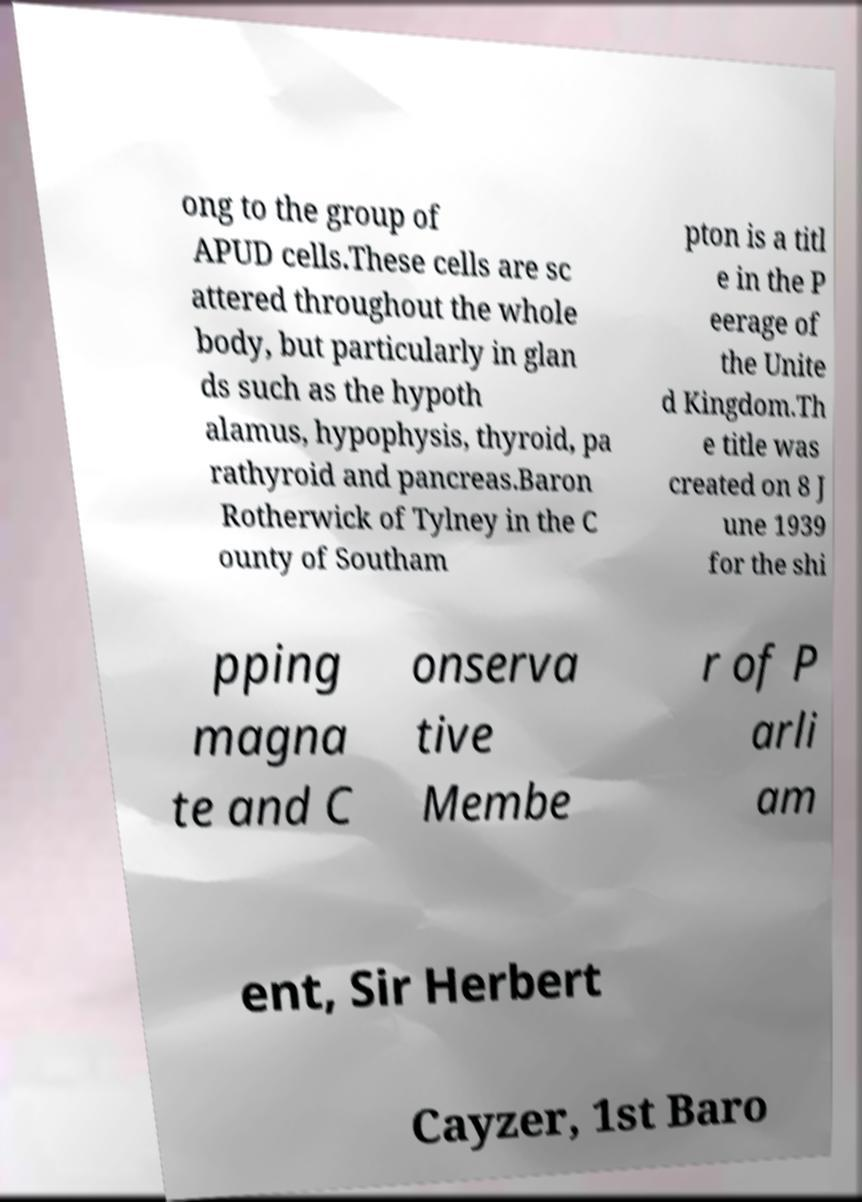Could you extract and type out the text from this image? ong to the group of APUD cells.These cells are sc attered throughout the whole body, but particularly in glan ds such as the hypoth alamus, hypophysis, thyroid, pa rathyroid and pancreas.Baron Rotherwick of Tylney in the C ounty of Southam pton is a titl e in the P eerage of the Unite d Kingdom.Th e title was created on 8 J une 1939 for the shi pping magna te and C onserva tive Membe r of P arli am ent, Sir Herbert Cayzer, 1st Baro 